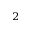<formula> <loc_0><loc_0><loc_500><loc_500>^ { 2 }</formula> 